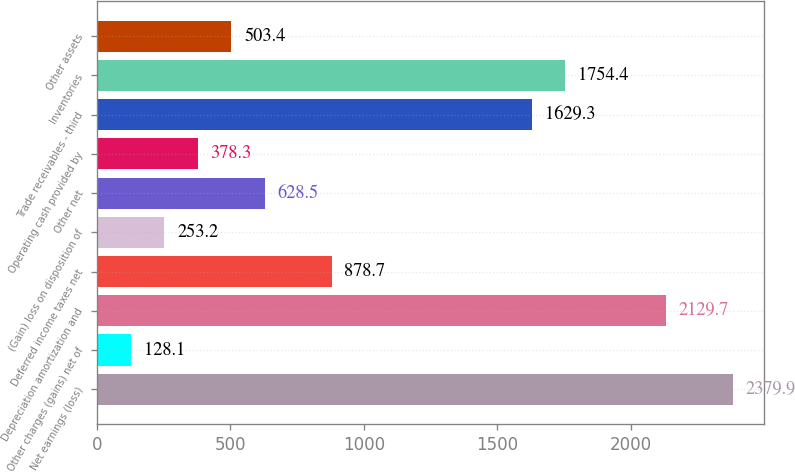<chart> <loc_0><loc_0><loc_500><loc_500><bar_chart><fcel>Net earnings (loss)<fcel>Other charges (gains) net of<fcel>Depreciation amortization and<fcel>Deferred income taxes net<fcel>(Gain) loss on disposition of<fcel>Other net<fcel>Operating cash provided by<fcel>Trade receivables - third<fcel>Inventories<fcel>Other assets<nl><fcel>2379.9<fcel>128.1<fcel>2129.7<fcel>878.7<fcel>253.2<fcel>628.5<fcel>378.3<fcel>1629.3<fcel>1754.4<fcel>503.4<nl></chart> 